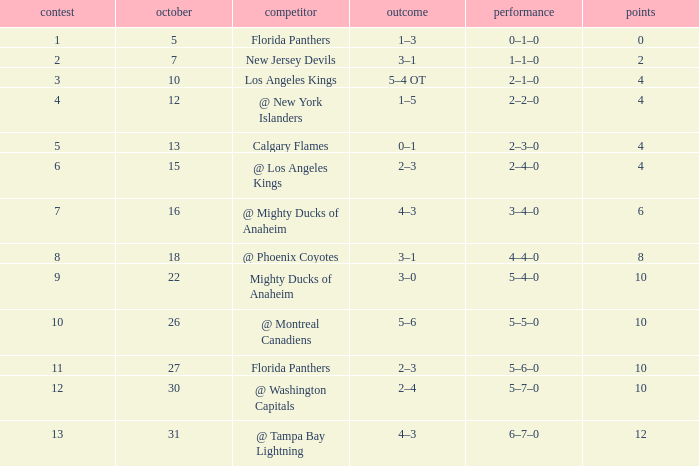What team has a score of 11 5–6–0. 